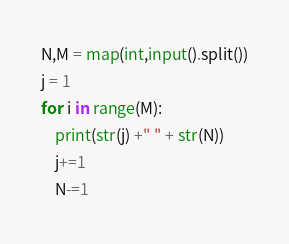Convert code to text. <code><loc_0><loc_0><loc_500><loc_500><_Python_>N,M = map(int,input().split())
j = 1
for i in range(M):
    print(str(j) +" " + str(N))
    j+=1
    N-=1
</code> 